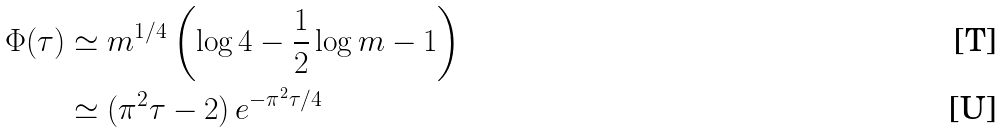<formula> <loc_0><loc_0><loc_500><loc_500>\Phi ( \tau ) & \simeq m ^ { 1 / 4 } \left ( \log 4 - \frac { 1 } { 2 } \log m - 1 \right ) \\ & \simeq ( \pi ^ { 2 } \tau - 2 ) \, e ^ { - \pi ^ { 2 } \tau / 4 }</formula> 